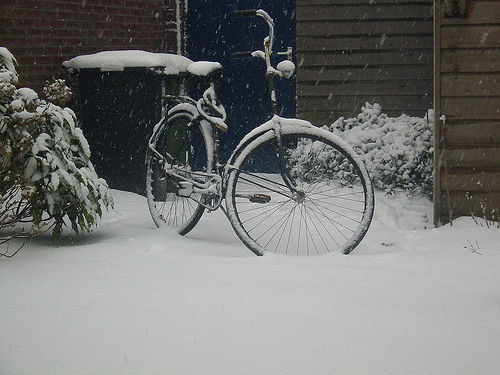Can you describe the surroundings in which the bicycle is placed? Certainly, the bicycle is situated in a serene, snow-covered outdoor scene, likely a home's front yard or a similar private property. The garden foliage is dusted with snow, and there's a wooden fence and a brick structure near the bike. The peaceful atmosphere is accentuated by the absence of any footprints or human activity in the immediate vicinity. 